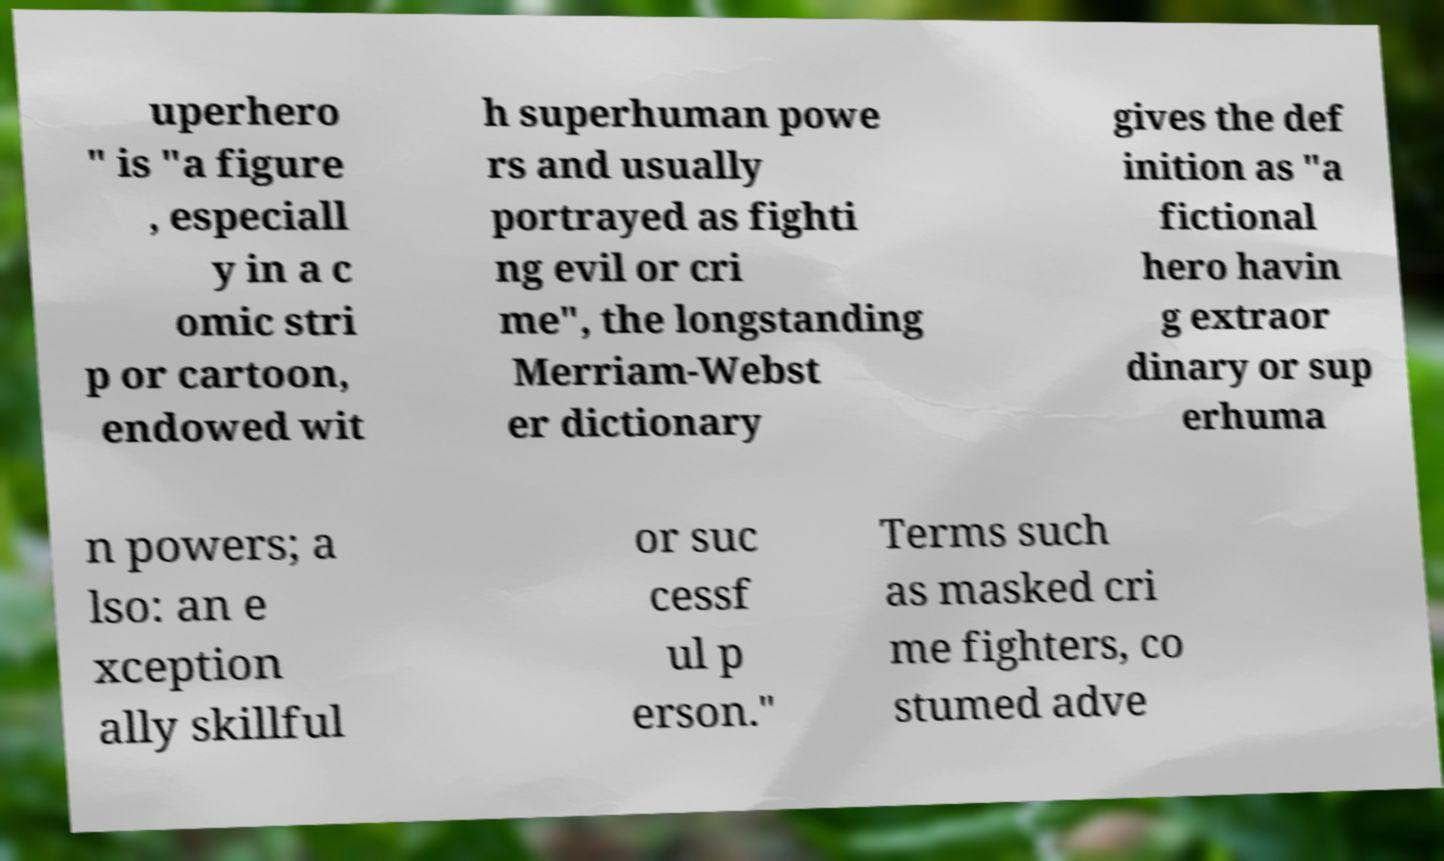Could you assist in decoding the text presented in this image and type it out clearly? uperhero " is "a figure , especiall y in a c omic stri p or cartoon, endowed wit h superhuman powe rs and usually portrayed as fighti ng evil or cri me", the longstanding Merriam-Webst er dictionary gives the def inition as "a fictional hero havin g extraor dinary or sup erhuma n powers; a lso: an e xception ally skillful or suc cessf ul p erson." Terms such as masked cri me fighters, co stumed adve 